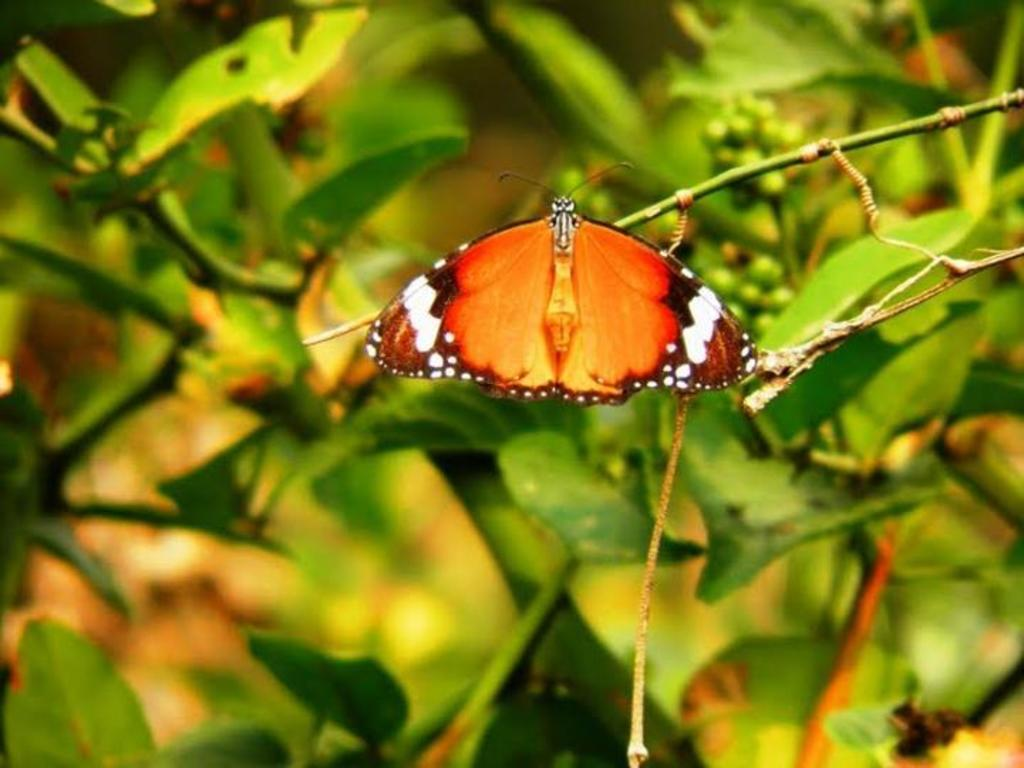What is the main subject of the image? There is a butterfly in the image. Where is the butterfly located? The butterfly is on a stem. What can be seen in the background of the image? The background of the image is blurred. What type of vegetation is visible in the image? There are leaves visible in the image. Is there a man holding a rod at a party in the image? No, there is no man, rod, or party depicted in the image. The image only features a butterfly on a stem with a blurred background and visible leaves. 